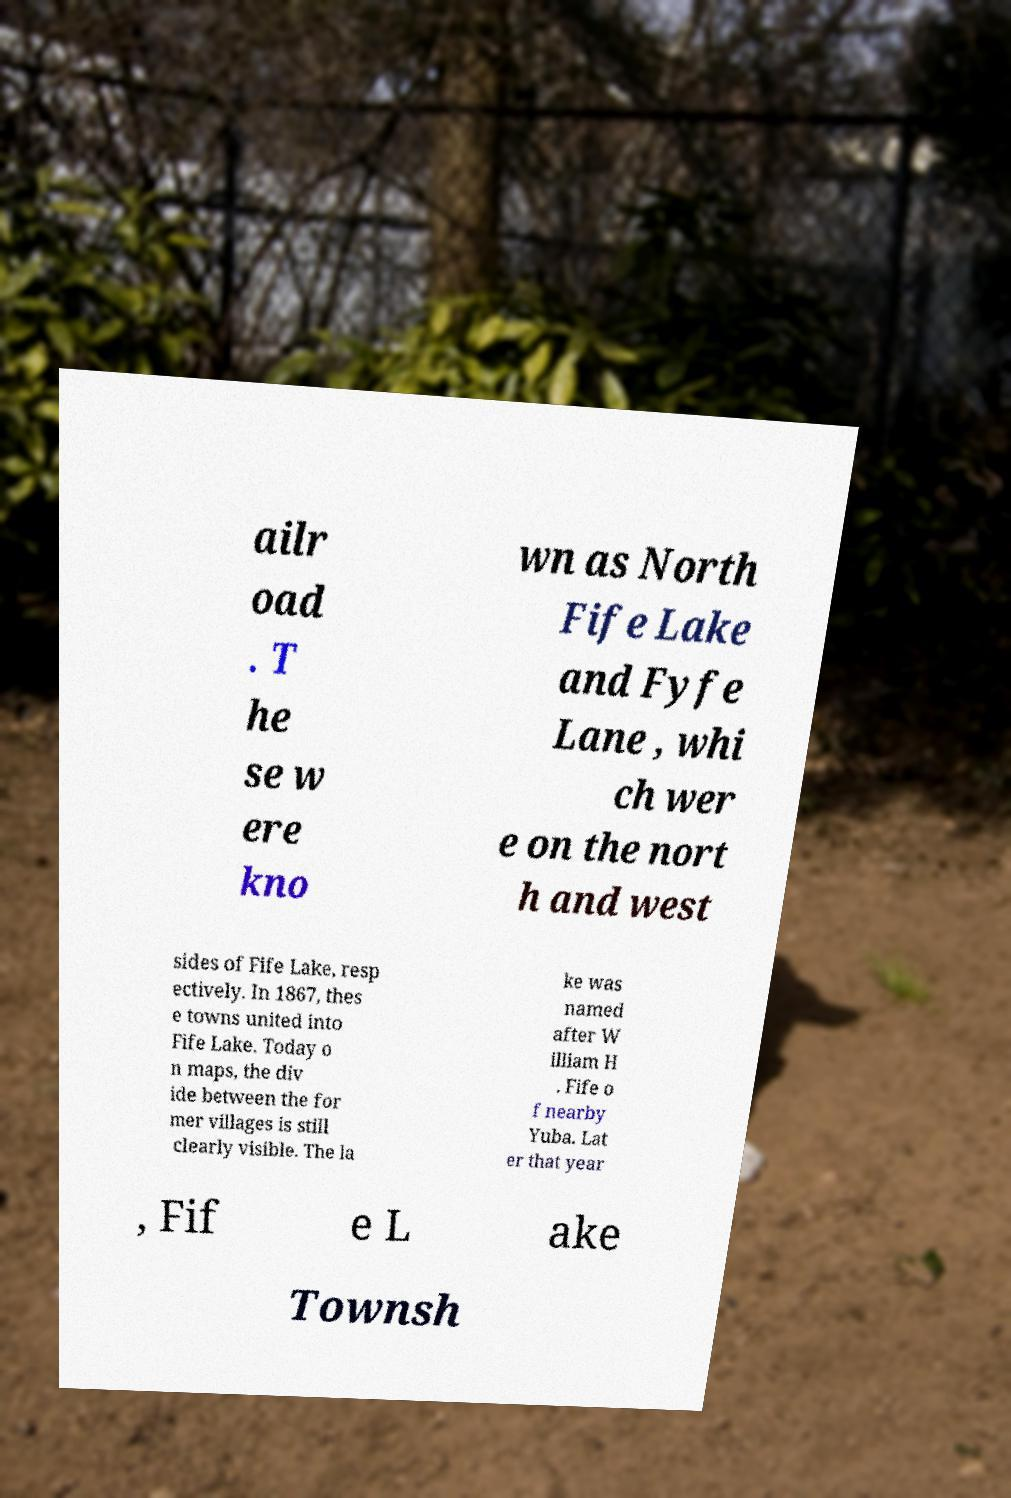For documentation purposes, I need the text within this image transcribed. Could you provide that? ailr oad . T he se w ere kno wn as North Fife Lake and Fyfe Lane , whi ch wer e on the nort h and west sides of Fife Lake, resp ectively. In 1867, thes e towns united into Fife Lake. Today o n maps, the div ide between the for mer villages is still clearly visible. The la ke was named after W illiam H . Fife o f nearby Yuba. Lat er that year , Fif e L ake Townsh 